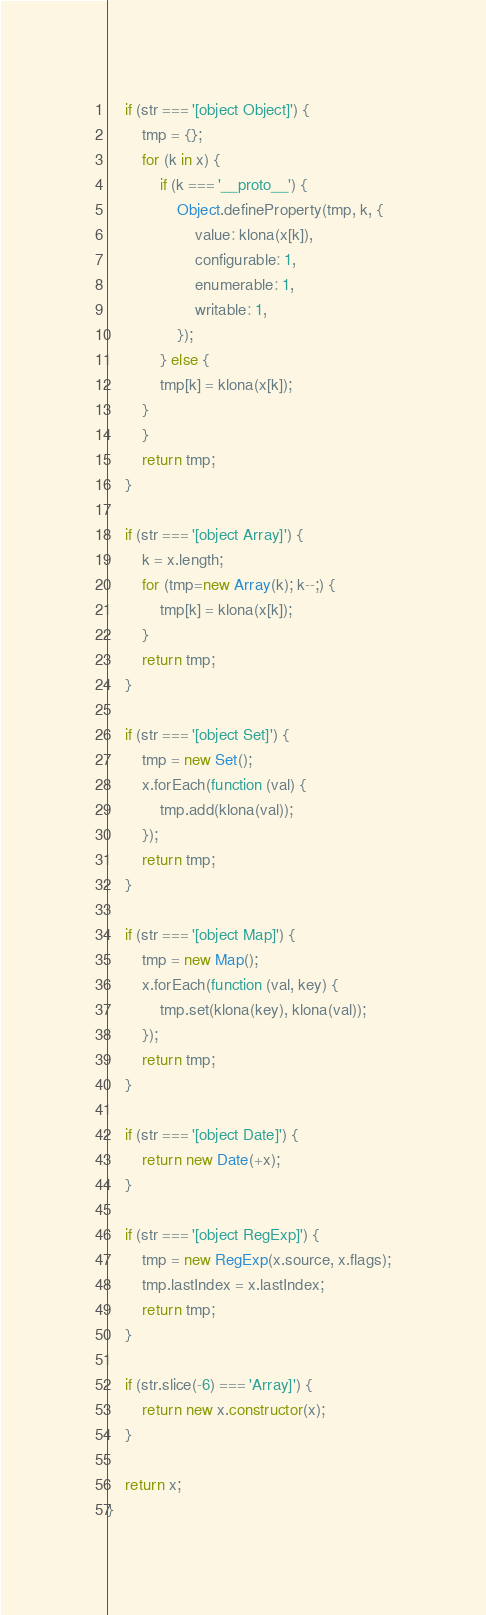<code> <loc_0><loc_0><loc_500><loc_500><_JavaScript_>	if (str === '[object Object]') {
		tmp = {};
		for (k in x) {
			if (k === '__proto__') {
				Object.defineProperty(tmp, k, {
					value: klona(x[k]),
					configurable: 1,
					enumerable: 1,
					writable: 1,
				});
			} else {
			tmp[k] = klona(x[k]);
		}
		}
		return tmp;
	}

	if (str === '[object Array]') {
		k = x.length;
		for (tmp=new Array(k); k--;) {
			tmp[k] = klona(x[k]);
		}
		return tmp;
	}

	if (str === '[object Set]') {
		tmp = new Set();
		x.forEach(function (val) {
			tmp.add(klona(val));
		});
		return tmp;
	}

	if (str === '[object Map]') {
		tmp = new Map();
		x.forEach(function (val, key) {
			tmp.set(klona(key), klona(val));
		});
		return tmp;
	}

	if (str === '[object Date]') {
		return new Date(+x);
	}

	if (str === '[object RegExp]') {
		tmp = new RegExp(x.source, x.flags);
		tmp.lastIndex = x.lastIndex;
		return tmp;
	}

	if (str.slice(-6) === 'Array]') {
		return new x.constructor(x);
	}

	return x;
}
</code> 